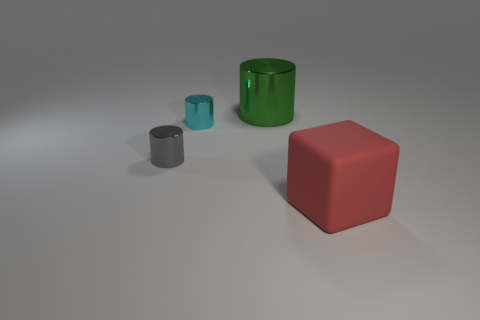Can you describe the lighting and shadows in the scene? The lighting in the scene is soft and appears to be coming from the upper left side, casting gentle, elongated shadows to the right of the objects, suggesting a calm and evenly lit environment. 